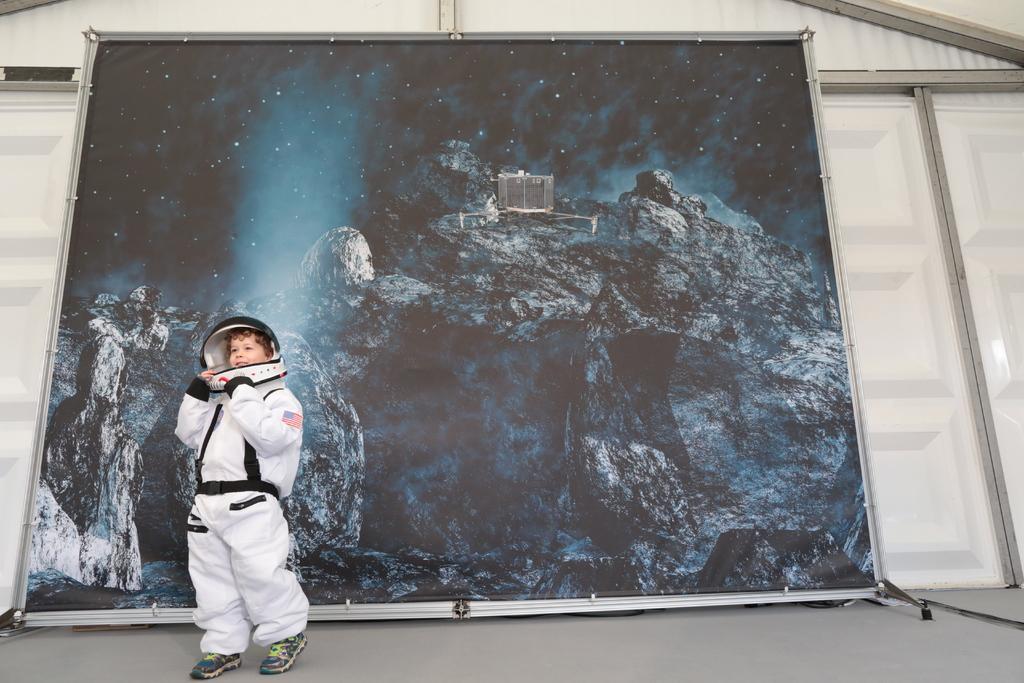Could you give a brief overview of what you see in this image? Here we can see a kid standing on the floor. In the background there is a banner. 